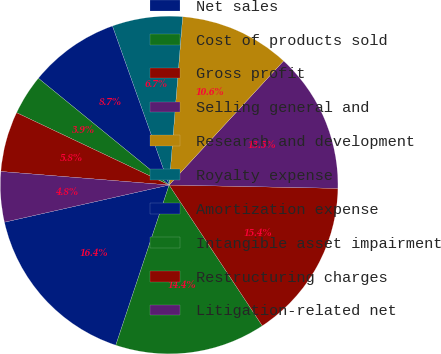Convert chart. <chart><loc_0><loc_0><loc_500><loc_500><pie_chart><fcel>Net sales<fcel>Cost of products sold<fcel>Gross profit<fcel>Selling general and<fcel>Research and development<fcel>Royalty expense<fcel>Amortization expense<fcel>Intangible asset impairment<fcel>Restructuring charges<fcel>Litigation-related net<nl><fcel>16.35%<fcel>14.42%<fcel>15.38%<fcel>13.46%<fcel>10.58%<fcel>6.73%<fcel>8.65%<fcel>3.85%<fcel>5.77%<fcel>4.81%<nl></chart> 